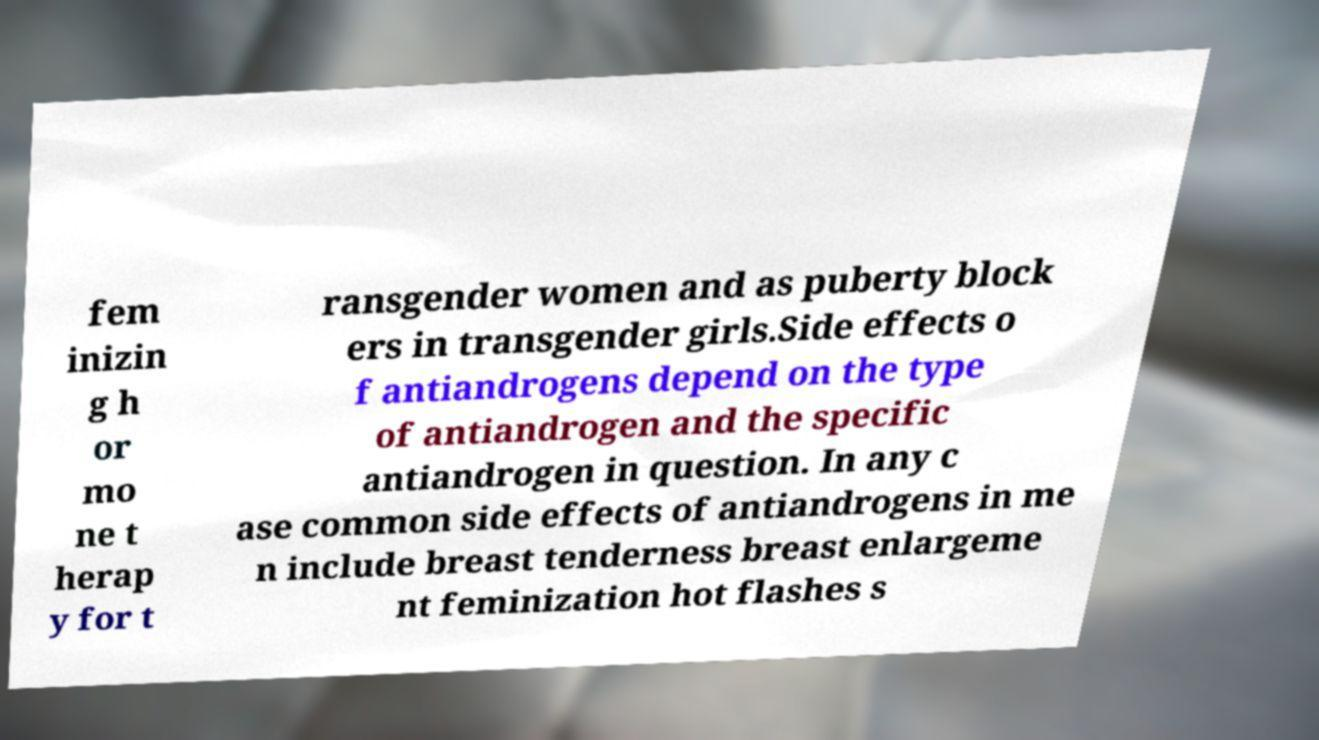Can you read and provide the text displayed in the image?This photo seems to have some interesting text. Can you extract and type it out for me? fem inizin g h or mo ne t herap y for t ransgender women and as puberty block ers in transgender girls.Side effects o f antiandrogens depend on the type of antiandrogen and the specific antiandrogen in question. In any c ase common side effects of antiandrogens in me n include breast tenderness breast enlargeme nt feminization hot flashes s 